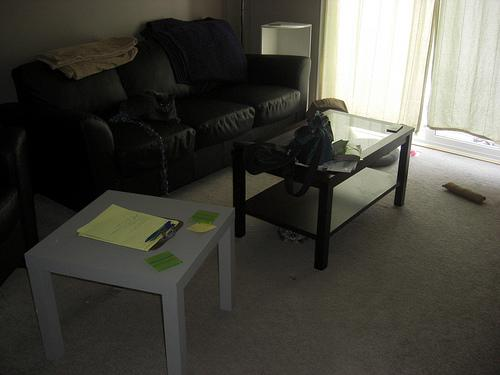Question: where was this taken?
Choices:
A. Living room.
B. Kitchen.
C. Dining room.
D. Hallway.
Answer with the letter. Answer: A Question: what is on the gray table?
Choices:
A. A clipboard and post-it notes.
B. A vase.
C. A lamp.
D. A typewriter.
Answer with the letter. Answer: A Question: who is on the couch?
Choices:
A. The cat.
B. A man.
C. A woman.
D. A dog.
Answer with the letter. Answer: A Question: why is the cat on the couch?
Choices:
A. It's resting.
B. It's sleeping.
C. It's relaxing.
D. It's afraid.
Answer with the letter. Answer: A Question: when was this taken?
Choices:
A. Yesterday.
B. This morning.
C. This afternoon.
D. During the day.
Answer with the letter. Answer: D Question: what is next to the gray table?
Choices:
A. A sofa.
B. A couch.
C. A coffee table.
D. A lamp.
Answer with the letter. Answer: C 